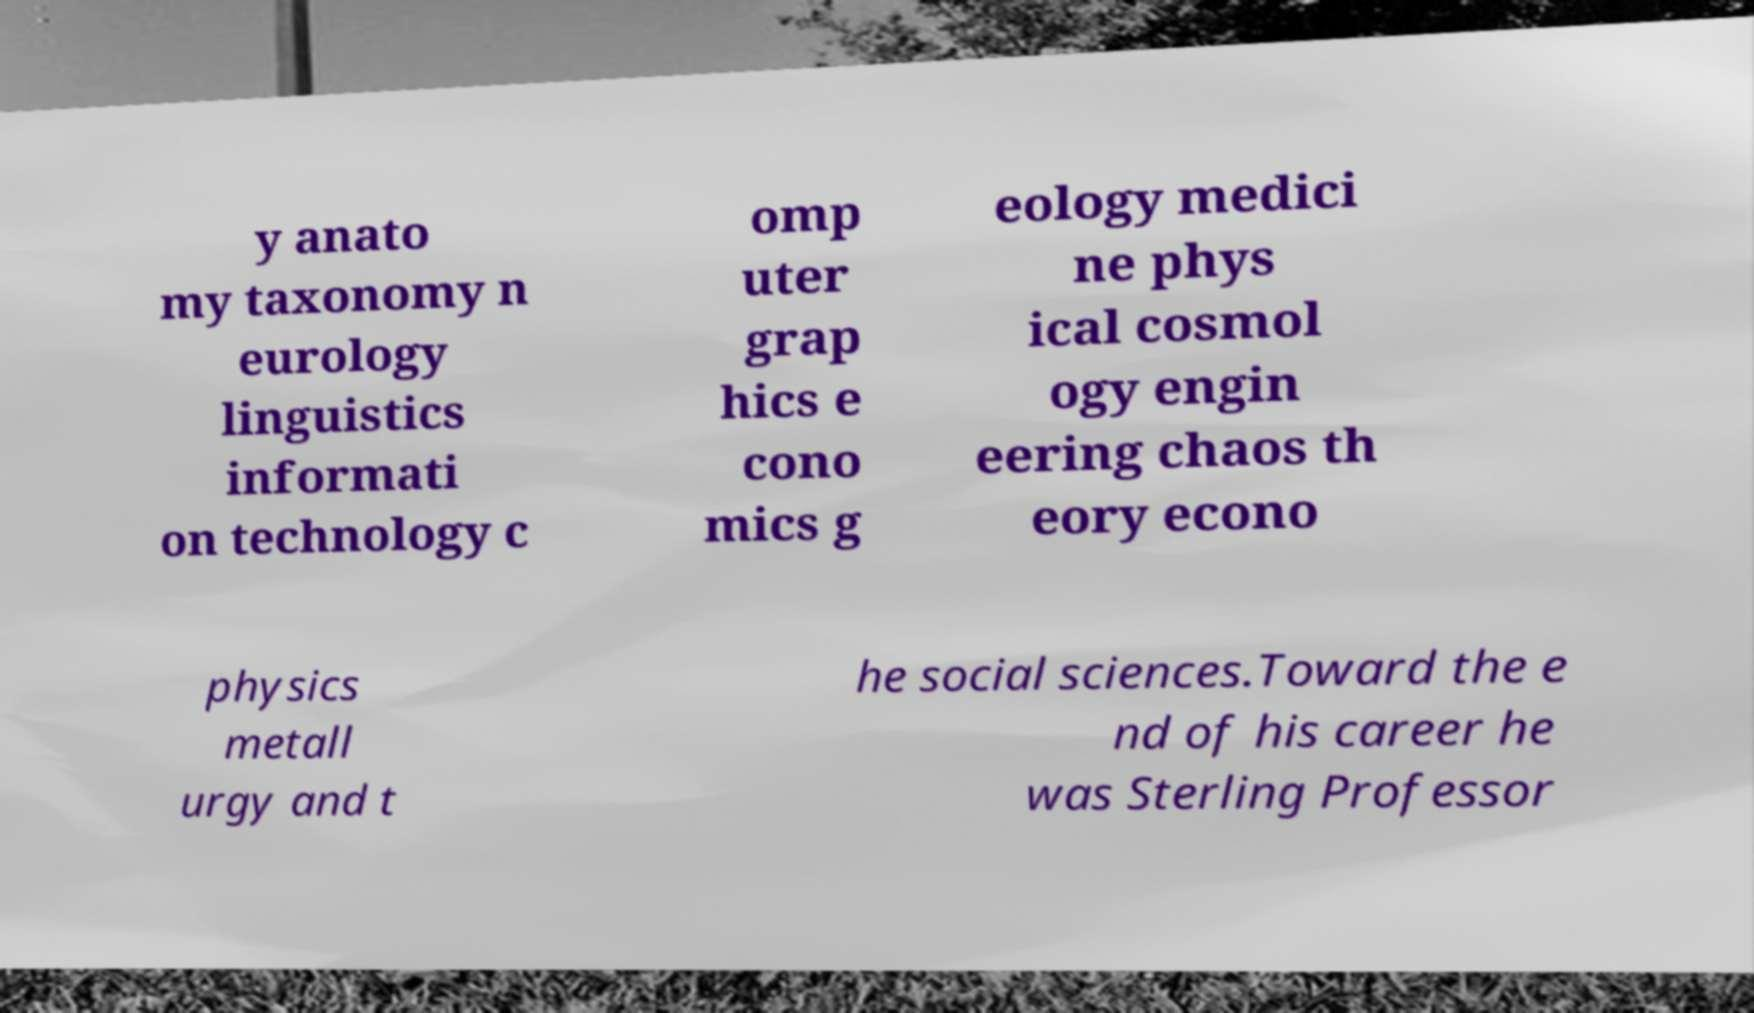Could you extract and type out the text from this image? y anato my taxonomy n eurology linguistics informati on technology c omp uter grap hics e cono mics g eology medici ne phys ical cosmol ogy engin eering chaos th eory econo physics metall urgy and t he social sciences.Toward the e nd of his career he was Sterling Professor 